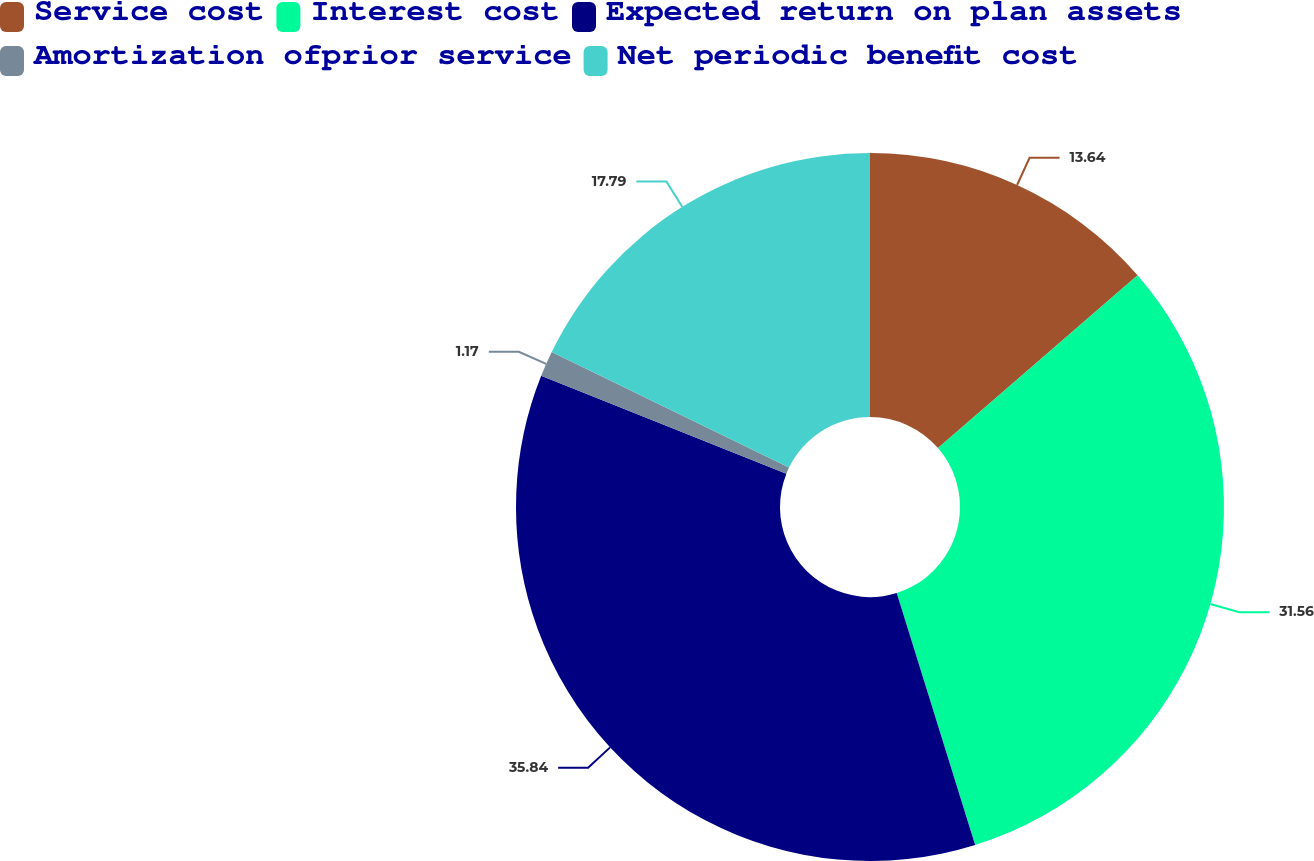<chart> <loc_0><loc_0><loc_500><loc_500><pie_chart><fcel>Service cost<fcel>Interest cost<fcel>Expected return on plan assets<fcel>Amortization ofprior service<fcel>Net periodic benefit cost<nl><fcel>13.64%<fcel>31.56%<fcel>35.84%<fcel>1.17%<fcel>17.79%<nl></chart> 